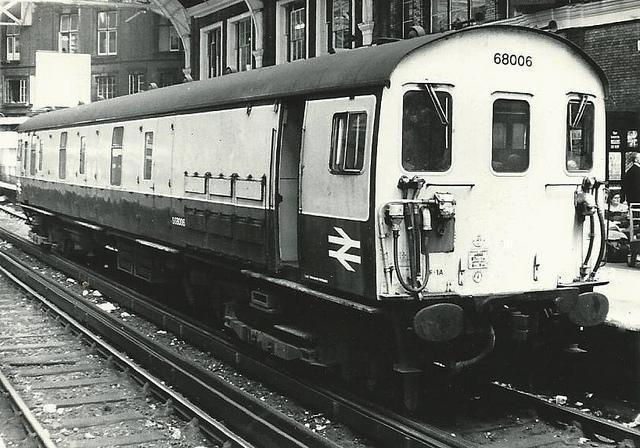What number is the largest number on the train?
Pick the right solution, then justify: 'Answer: answer
Rationale: rationale.'
Options: Five, two, eight, seven. Answer: eight.
Rationale: There is a five digit number on the front of the train. 7, 5, and 2 are not in this number. 